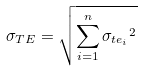Convert formula to latex. <formula><loc_0><loc_0><loc_500><loc_500>\sigma _ { T E } = \sqrt { \sum _ { i = 1 } ^ { n } { \sigma _ { t e _ { i } } } ^ { 2 } }</formula> 